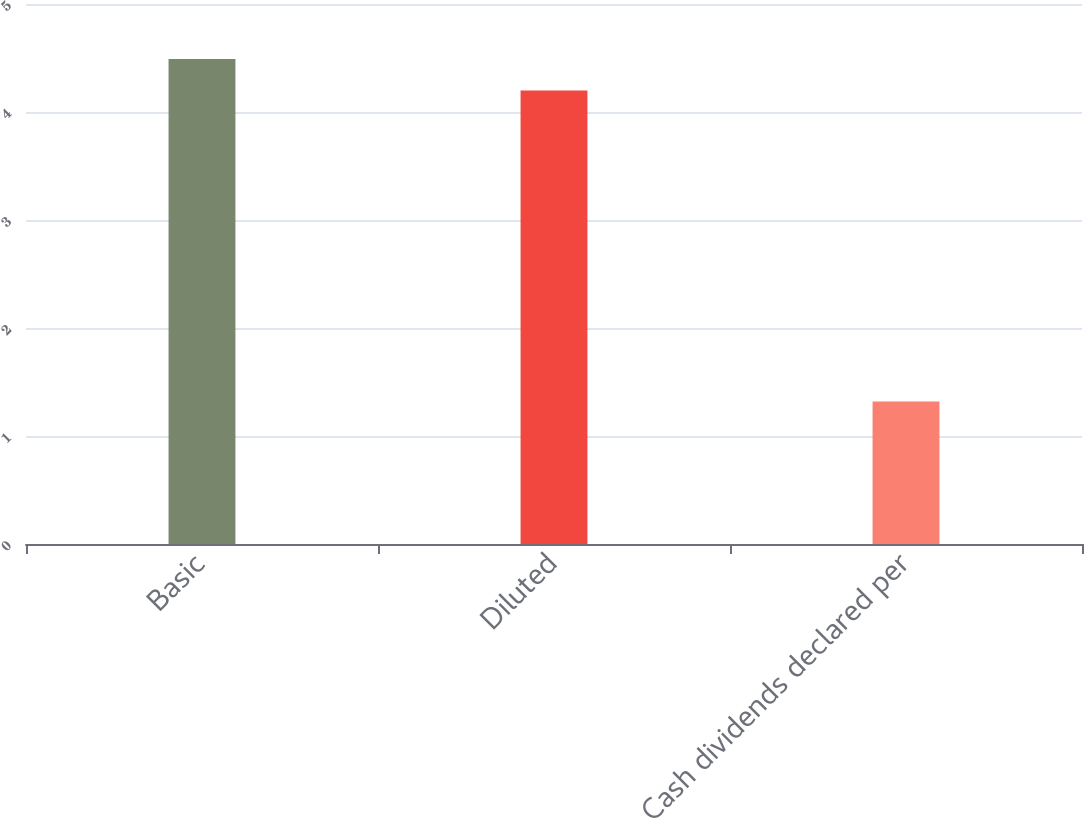Convert chart. <chart><loc_0><loc_0><loc_500><loc_500><bar_chart><fcel>Basic<fcel>Diluted<fcel>Cash dividends declared per<nl><fcel>4.49<fcel>4.2<fcel>1.32<nl></chart> 